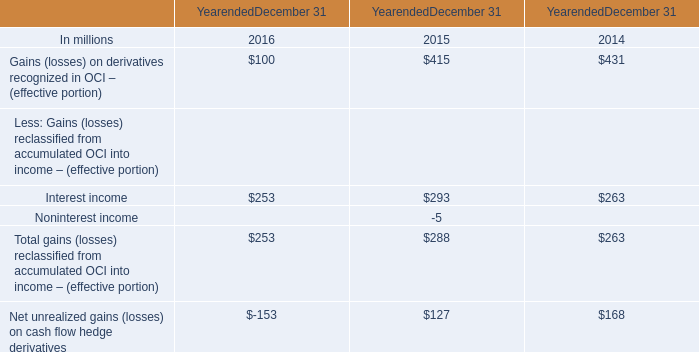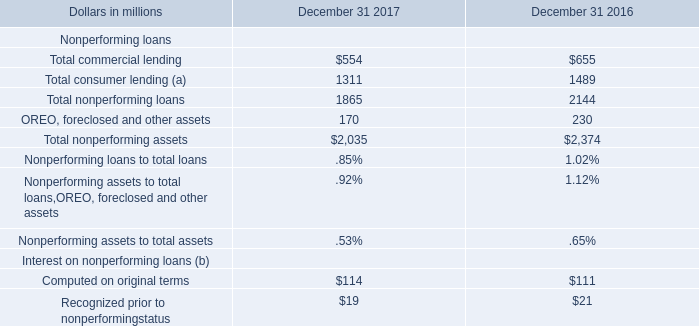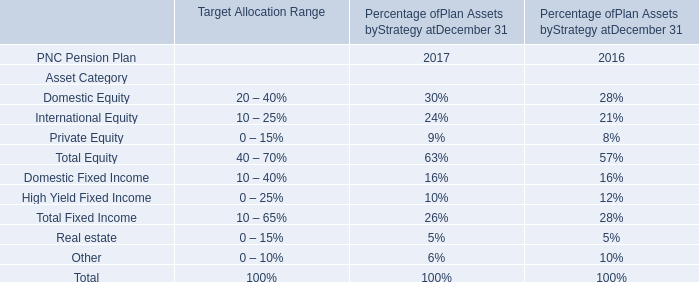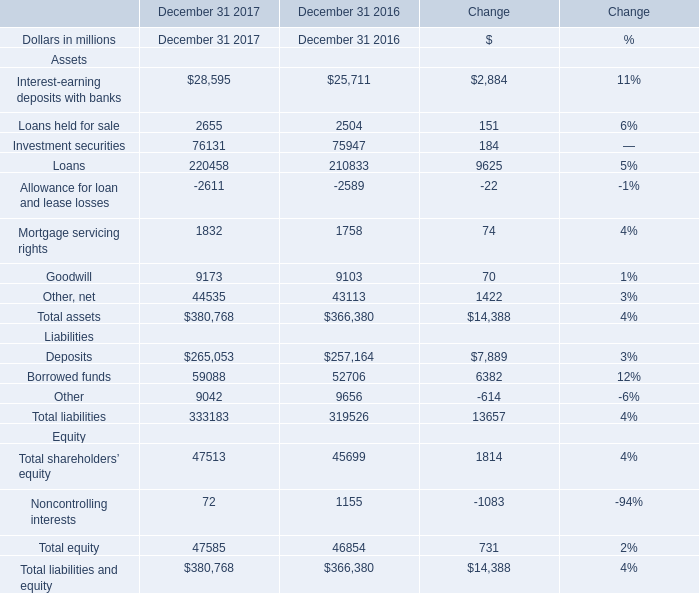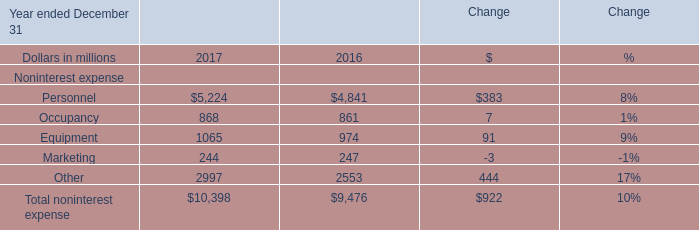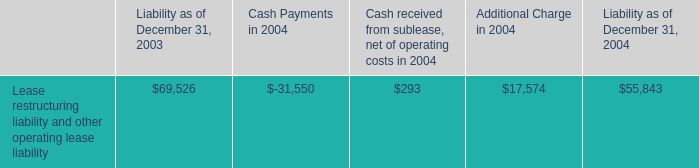Is the total amount of all elements in2017 greater than that in 2016? 
Answer: yes. 